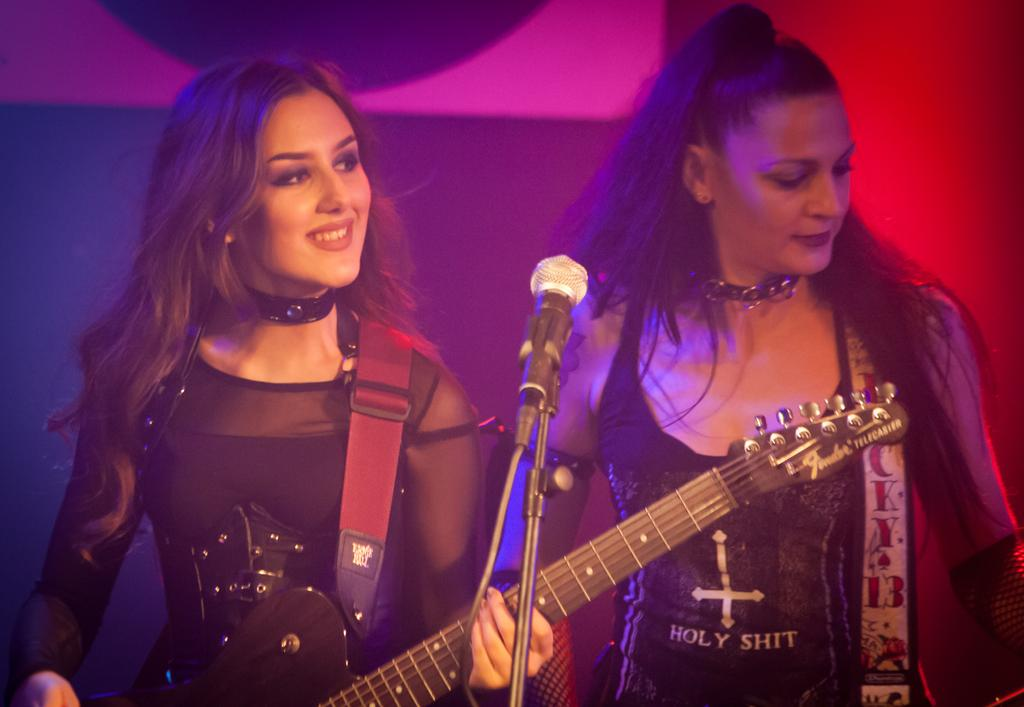How many people are in the image? There are two women in the image. What are the women holding in the image? The women are holding guitars. What expression do the women have in the image? The women are smiling. What object is in front of the women? There is a microphone (mic) in front of the women. What type of competition is the women participating in after their performance? There is no information about a competition or any performance in the image, so it cannot be determined from the image. 